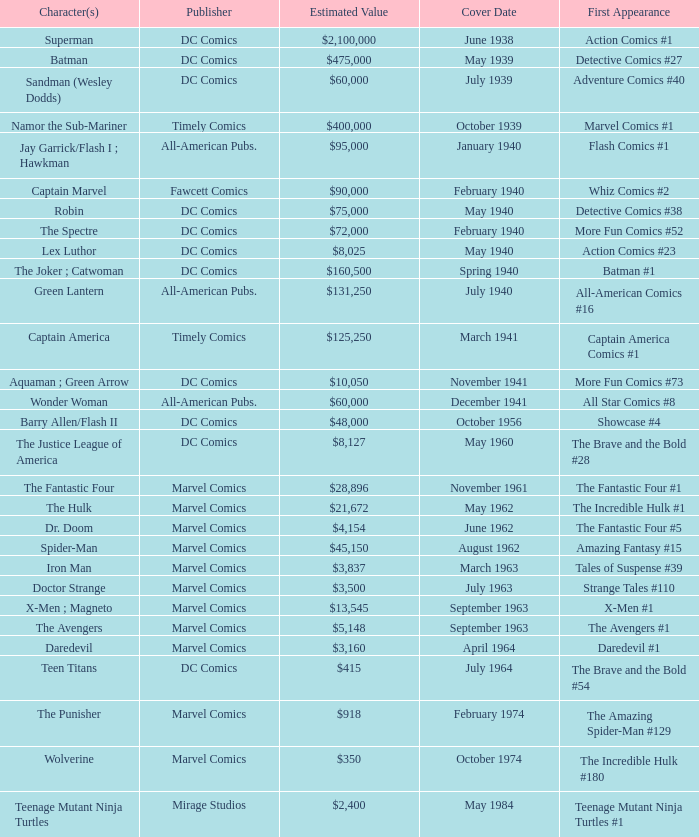Who publishes Wolverine? Marvel Comics. 